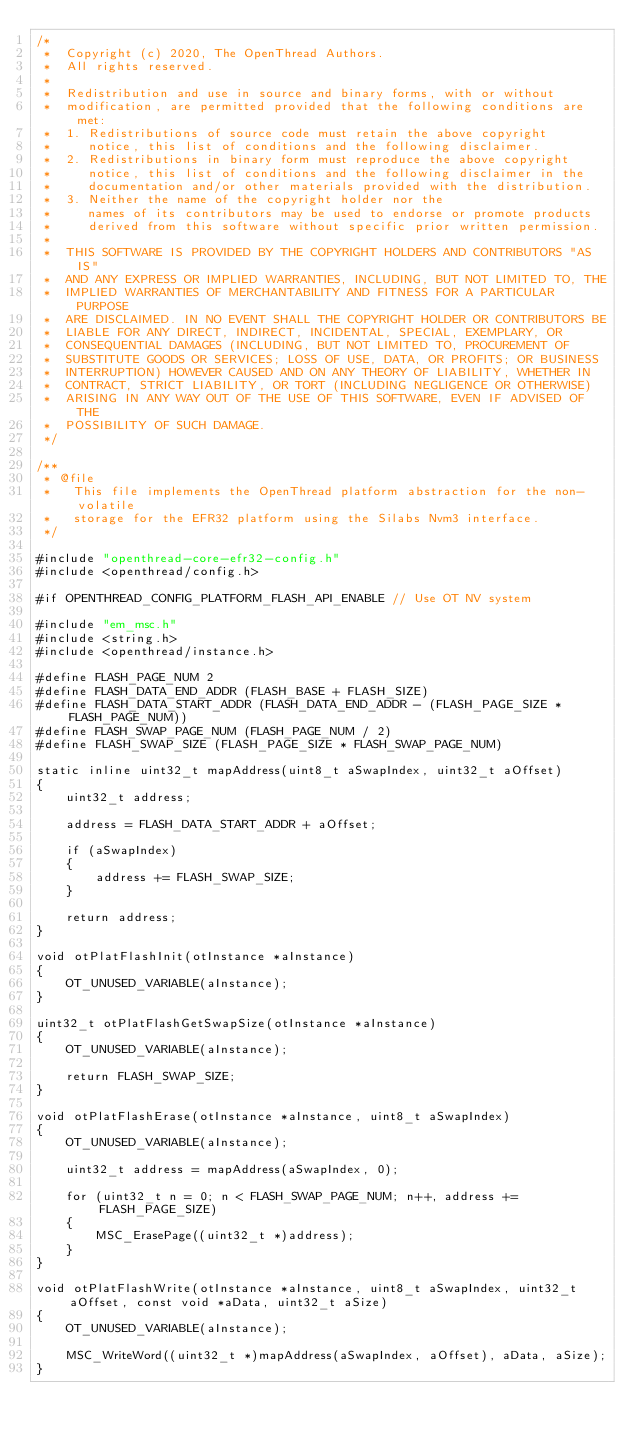<code> <loc_0><loc_0><loc_500><loc_500><_C_>/*
 *  Copyright (c) 2020, The OpenThread Authors.
 *  All rights reserved.
 *
 *  Redistribution and use in source and binary forms, with or without
 *  modification, are permitted provided that the following conditions are met:
 *  1. Redistributions of source code must retain the above copyright
 *     notice, this list of conditions and the following disclaimer.
 *  2. Redistributions in binary form must reproduce the above copyright
 *     notice, this list of conditions and the following disclaimer in the
 *     documentation and/or other materials provided with the distribution.
 *  3. Neither the name of the copyright holder nor the
 *     names of its contributors may be used to endorse or promote products
 *     derived from this software without specific prior written permission.
 *
 *  THIS SOFTWARE IS PROVIDED BY THE COPYRIGHT HOLDERS AND CONTRIBUTORS "AS IS"
 *  AND ANY EXPRESS OR IMPLIED WARRANTIES, INCLUDING, BUT NOT LIMITED TO, THE
 *  IMPLIED WARRANTIES OF MERCHANTABILITY AND FITNESS FOR A PARTICULAR PURPOSE
 *  ARE DISCLAIMED. IN NO EVENT SHALL THE COPYRIGHT HOLDER OR CONTRIBUTORS BE
 *  LIABLE FOR ANY DIRECT, INDIRECT, INCIDENTAL, SPECIAL, EXEMPLARY, OR
 *  CONSEQUENTIAL DAMAGES (INCLUDING, BUT NOT LIMITED TO, PROCUREMENT OF
 *  SUBSTITUTE GOODS OR SERVICES; LOSS OF USE, DATA, OR PROFITS; OR BUSINESS
 *  INTERRUPTION) HOWEVER CAUSED AND ON ANY THEORY OF LIABILITY, WHETHER IN
 *  CONTRACT, STRICT LIABILITY, OR TORT (INCLUDING NEGLIGENCE OR OTHERWISE)
 *  ARISING IN ANY WAY OUT OF THE USE OF THIS SOFTWARE, EVEN IF ADVISED OF THE
 *  POSSIBILITY OF SUCH DAMAGE.
 */

/**
 * @file
 *   This file implements the OpenThread platform abstraction for the non-volatile
 *   storage for the EFR32 platform using the Silabs Nvm3 interface.
 */

#include "openthread-core-efr32-config.h"
#include <openthread/config.h>

#if OPENTHREAD_CONFIG_PLATFORM_FLASH_API_ENABLE // Use OT NV system

#include "em_msc.h"
#include <string.h>
#include <openthread/instance.h>

#define FLASH_PAGE_NUM 2
#define FLASH_DATA_END_ADDR (FLASH_BASE + FLASH_SIZE)
#define FLASH_DATA_START_ADDR (FLASH_DATA_END_ADDR - (FLASH_PAGE_SIZE * FLASH_PAGE_NUM))
#define FLASH_SWAP_PAGE_NUM (FLASH_PAGE_NUM / 2)
#define FLASH_SWAP_SIZE (FLASH_PAGE_SIZE * FLASH_SWAP_PAGE_NUM)

static inline uint32_t mapAddress(uint8_t aSwapIndex, uint32_t aOffset)
{
    uint32_t address;

    address = FLASH_DATA_START_ADDR + aOffset;

    if (aSwapIndex)
    {
        address += FLASH_SWAP_SIZE;
    }

    return address;
}

void otPlatFlashInit(otInstance *aInstance)
{
    OT_UNUSED_VARIABLE(aInstance);
}

uint32_t otPlatFlashGetSwapSize(otInstance *aInstance)
{
    OT_UNUSED_VARIABLE(aInstance);

    return FLASH_SWAP_SIZE;
}

void otPlatFlashErase(otInstance *aInstance, uint8_t aSwapIndex)
{
    OT_UNUSED_VARIABLE(aInstance);

    uint32_t address = mapAddress(aSwapIndex, 0);

    for (uint32_t n = 0; n < FLASH_SWAP_PAGE_NUM; n++, address += FLASH_PAGE_SIZE)
    {
        MSC_ErasePage((uint32_t *)address);
    }
}

void otPlatFlashWrite(otInstance *aInstance, uint8_t aSwapIndex, uint32_t aOffset, const void *aData, uint32_t aSize)
{
    OT_UNUSED_VARIABLE(aInstance);

    MSC_WriteWord((uint32_t *)mapAddress(aSwapIndex, aOffset), aData, aSize);
}
</code> 